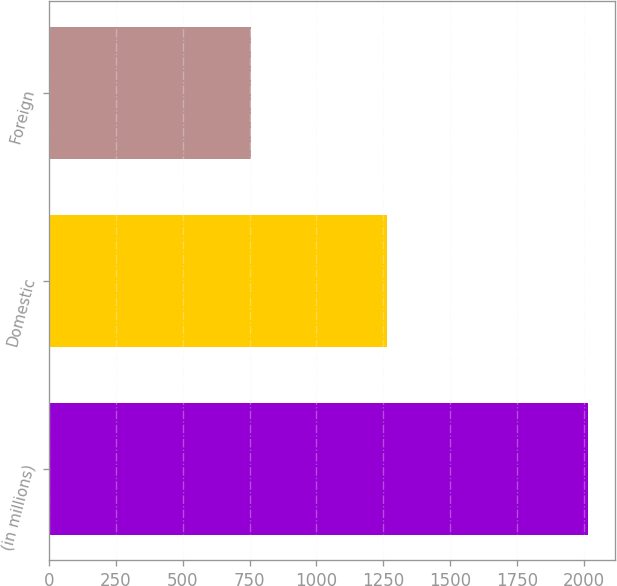Convert chart to OTSL. <chart><loc_0><loc_0><loc_500><loc_500><bar_chart><fcel>(in millions)<fcel>Domestic<fcel>Foreign<nl><fcel>2014<fcel>1263<fcel>754<nl></chart> 